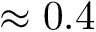Convert formula to latex. <formula><loc_0><loc_0><loc_500><loc_500>\approx 0 . 4</formula> 